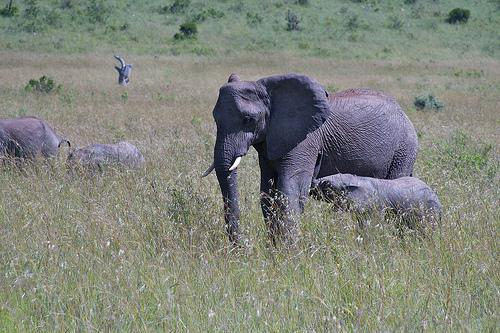Question: when was the photo taken?
Choices:
A. During the fire.
B. During the day.
C. During the ice storm.
D. During the march.
Answer with the letter. Answer: B Question: what color is the elephant?
Choices:
A. Brown.
B. Silver.
C. Grey.
D. White.
Answer with the letter. Answer: C Question: who is in the photo?
Choices:
A. Everyone.
B. You.
C. Me.
D. Nobody.
Answer with the letter. Answer: D Question: what color is the grass?
Choices:
A. Green.
B. Dark green.
C. Brown.
D. Tan.
Answer with the letter. Answer: C 